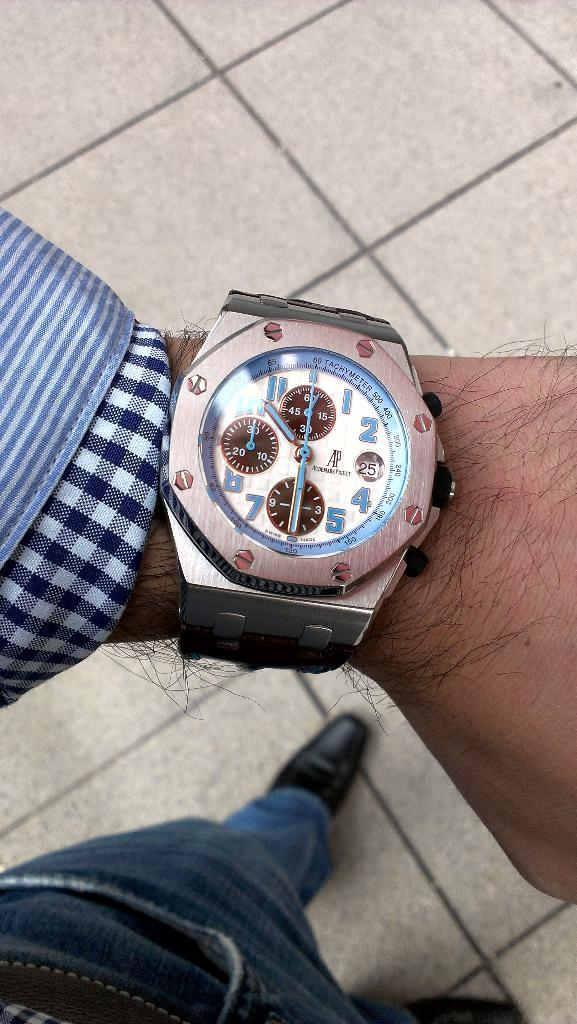Provide a one-sentence caption for the provided image. 10 thrity is the time acorrding to the watch. 